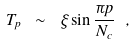Convert formula to latex. <formula><loc_0><loc_0><loc_500><loc_500>T _ { p } \ \sim \ \xi \sin \frac { \pi p } { N _ { c } } \ ,</formula> 